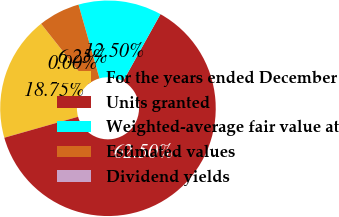Convert chart. <chart><loc_0><loc_0><loc_500><loc_500><pie_chart><fcel>For the years ended December<fcel>Units granted<fcel>Weighted-average fair value at<fcel>Estimated values<fcel>Dividend yields<nl><fcel>18.75%<fcel>62.5%<fcel>12.5%<fcel>6.25%<fcel>0.0%<nl></chart> 